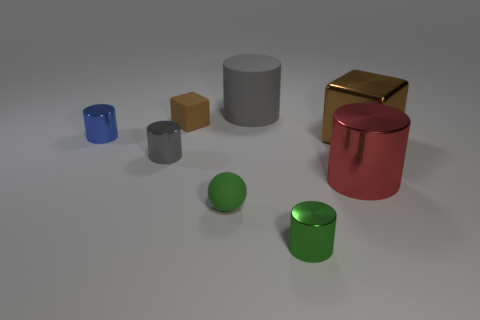What is the size of the brown metallic object that is the same shape as the small brown rubber object?
Your answer should be very brief. Large. What is the size of the cylinder that is the same color as the rubber ball?
Ensure brevity in your answer.  Small. What number of balls have the same color as the tiny cube?
Make the answer very short. 0. How many other things are there of the same size as the brown matte object?
Your answer should be very brief. 4. There is a object that is to the right of the tiny green rubber sphere and in front of the red object; what is its size?
Keep it short and to the point. Small. What number of other big objects have the same shape as the big gray object?
Your answer should be very brief. 1. What is the large brown cube made of?
Provide a short and direct response. Metal. Is the blue metal object the same shape as the small gray metal object?
Provide a short and direct response. Yes. Are there any small red things made of the same material as the large red thing?
Your answer should be compact. No. What is the color of the metal object that is both to the right of the matte ball and behind the big red cylinder?
Make the answer very short. Brown. 